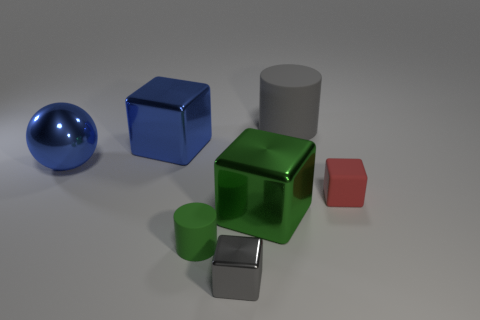Subtract all tiny shiny blocks. How many blocks are left? 3 Add 3 blue shiny things. How many objects exist? 10 Subtract all red blocks. How many blocks are left? 3 Subtract 1 cylinders. How many cylinders are left? 1 Subtract all brown cubes. How many gray cylinders are left? 1 Subtract all blocks. How many objects are left? 3 Add 2 gray metallic objects. How many gray metallic objects are left? 3 Add 4 tiny metallic objects. How many tiny metallic objects exist? 5 Subtract 0 gray spheres. How many objects are left? 7 Subtract all blue cylinders. Subtract all cyan cubes. How many cylinders are left? 2 